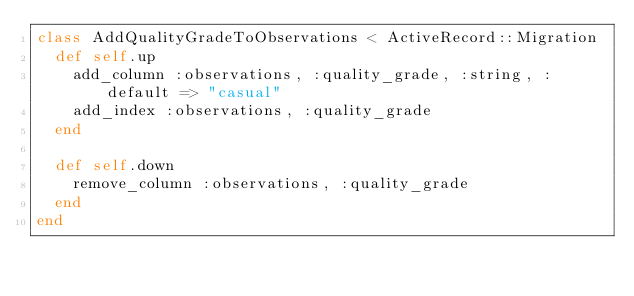<code> <loc_0><loc_0><loc_500><loc_500><_Ruby_>class AddQualityGradeToObservations < ActiveRecord::Migration
  def self.up
    add_column :observations, :quality_grade, :string, :default => "casual"
    add_index :observations, :quality_grade
  end

  def self.down
    remove_column :observations, :quality_grade
  end
end
</code> 